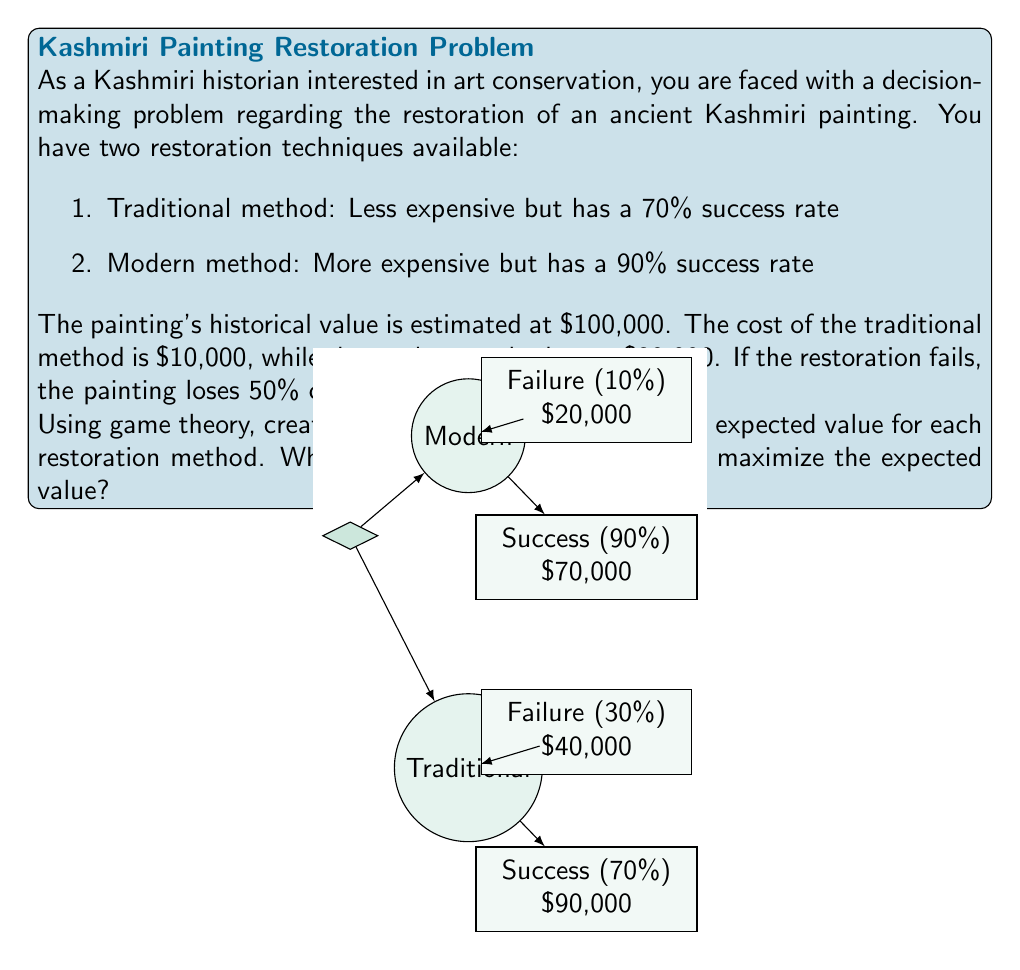Can you solve this math problem? Let's approach this problem step-by-step using decision theory:

1. First, let's calculate the outcomes for each scenario:

   Traditional method:
   - Success: $100,000 - $10,000 = $90,000
   - Failure: ($100,000 × 0.5) - $10,000 = $40,000

   Modern method:
   - Success: $100,000 - $30,000 = $70,000
   - Failure: ($100,000 × 0.5) - $30,000 = $20,000

2. Now, let's calculate the expected value (EV) for each method:

   Traditional method:
   $$EV_{traditional} = (0.7 × $90,000) + (0.3 × $40,000)$$
   $$EV_{traditional} = $63,000 + $12,000 = $75,000$$

   Modern method:
   $$EV_{modern} = (0.9 × $70,000) + (0.1 × $20,000)$$
   $$EV_{modern} = $63,000 + $2,000 = $65,000$$

3. Compare the expected values:
   The traditional method has a higher expected value ($75,000) compared to the modern method ($65,000).

4. Decision rule:
   In decision theory, we choose the option with the highest expected value to maximize our outcome.

Therefore, based on the expected value calculation, you should choose the traditional restoration method to maximize the expected value.
Answer: Choose the traditional restoration method (EV = $75,000). 